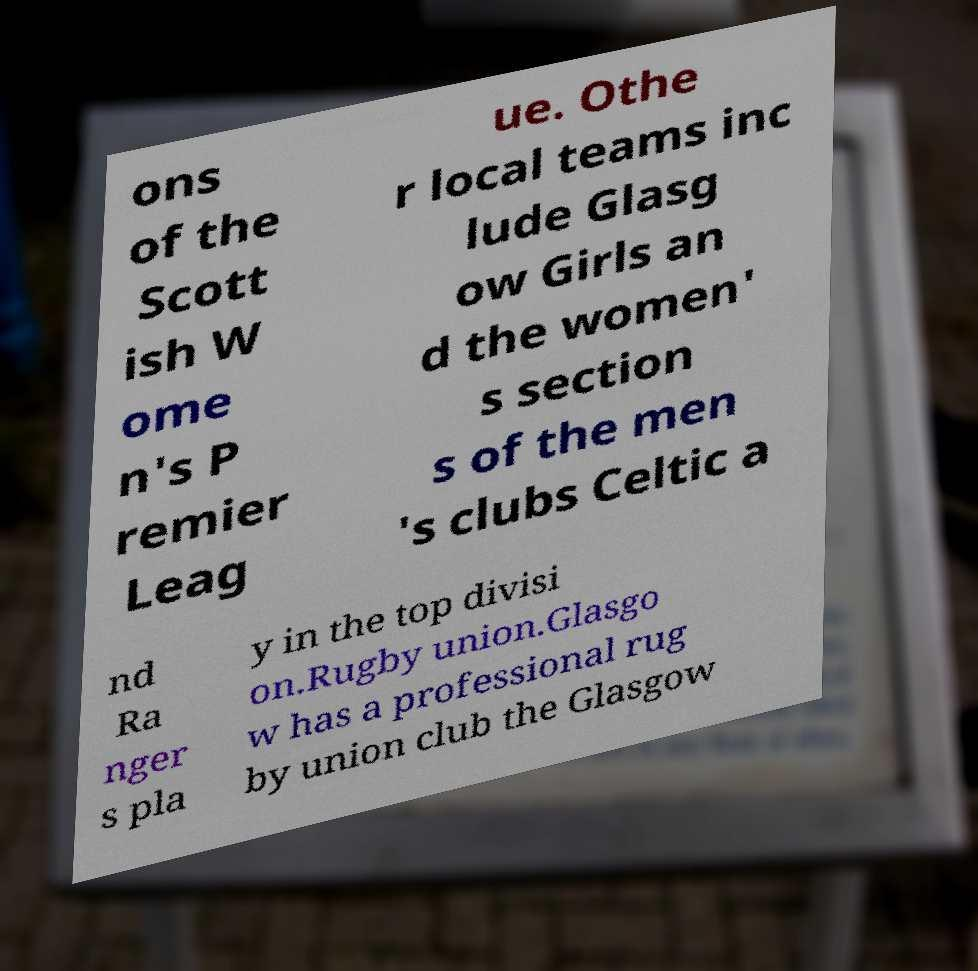Please identify and transcribe the text found in this image. ons of the Scott ish W ome n's P remier Leag ue. Othe r local teams inc lude Glasg ow Girls an d the women' s section s of the men 's clubs Celtic a nd Ra nger s pla y in the top divisi on.Rugby union.Glasgo w has a professional rug by union club the Glasgow 